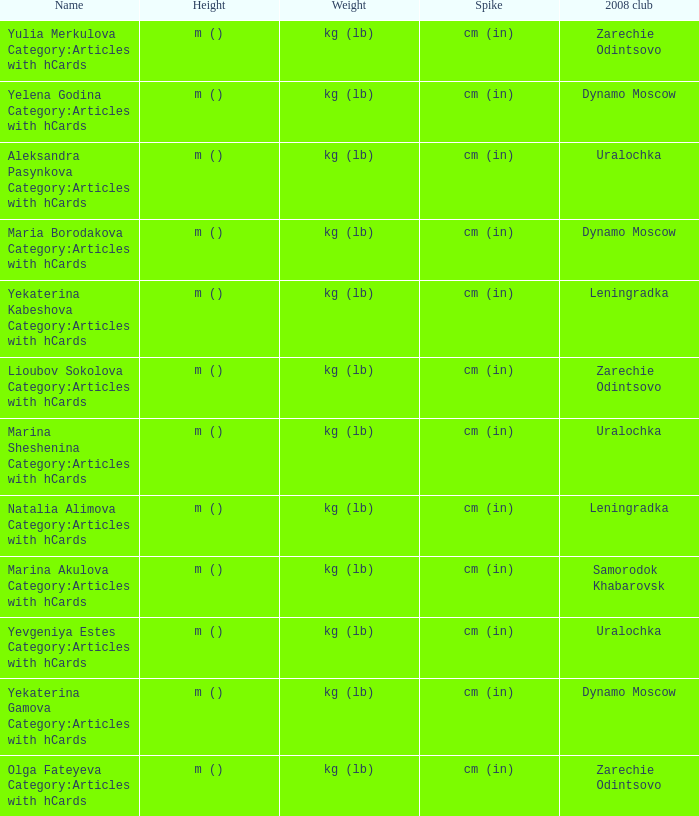What is the name when the 2008 club is zarechie odintsovo? Olga Fateyeva Category:Articles with hCards, Lioubov Sokolova Category:Articles with hCards, Yulia Merkulova Category:Articles with hCards. 